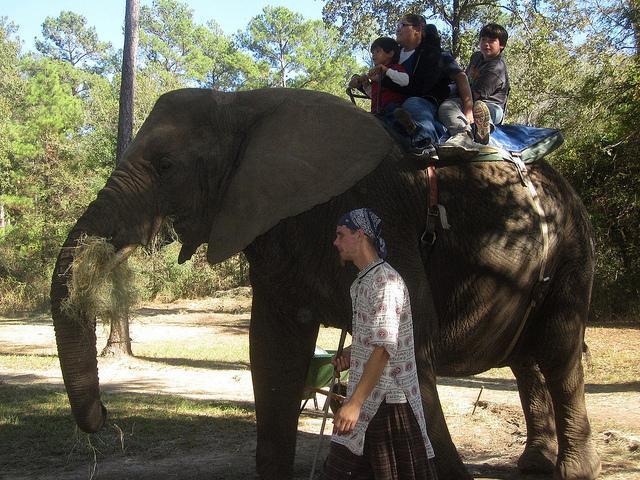How many people are on the elephant?
Give a very brief answer. 3. How many people are in this picture?
Give a very brief answer. 4. How many people are on top of the elephant?
Give a very brief answer. 4. How many people can be seen?
Give a very brief answer. 4. 